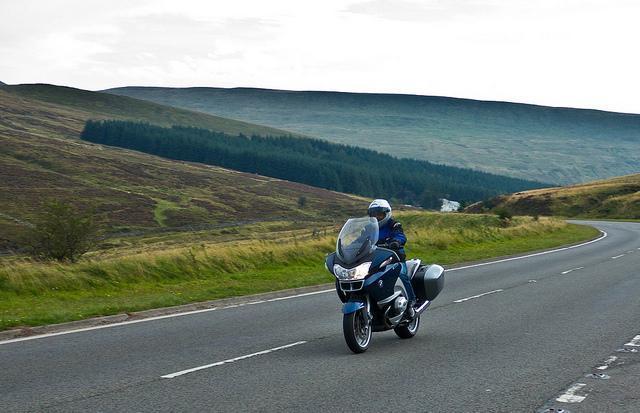How many lanes are on this road?
Give a very brief answer. 2. How many people are on the motorcycle?
Give a very brief answer. 1. How many motorcycles are there?
Give a very brief answer. 1. 